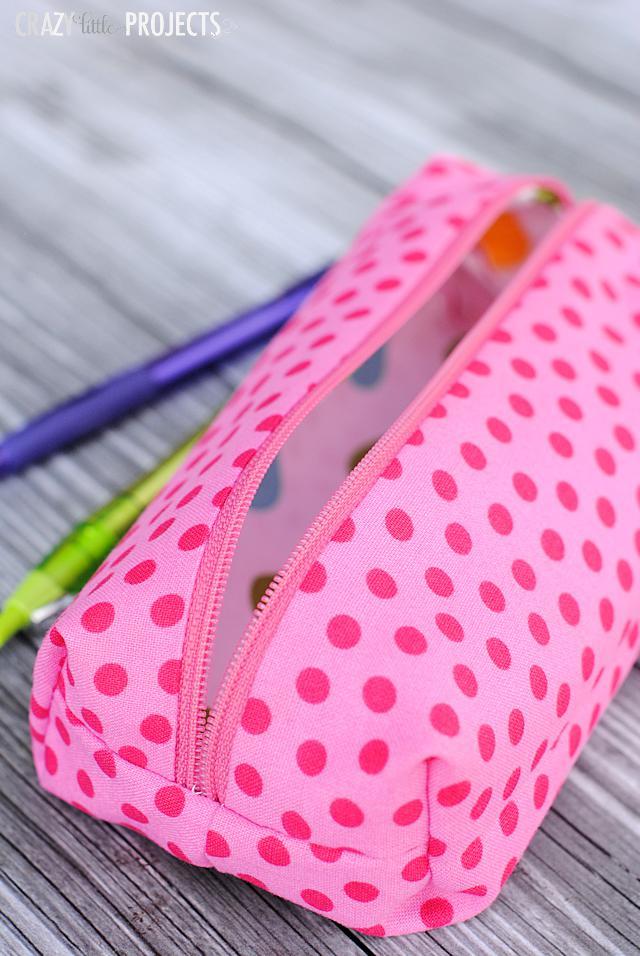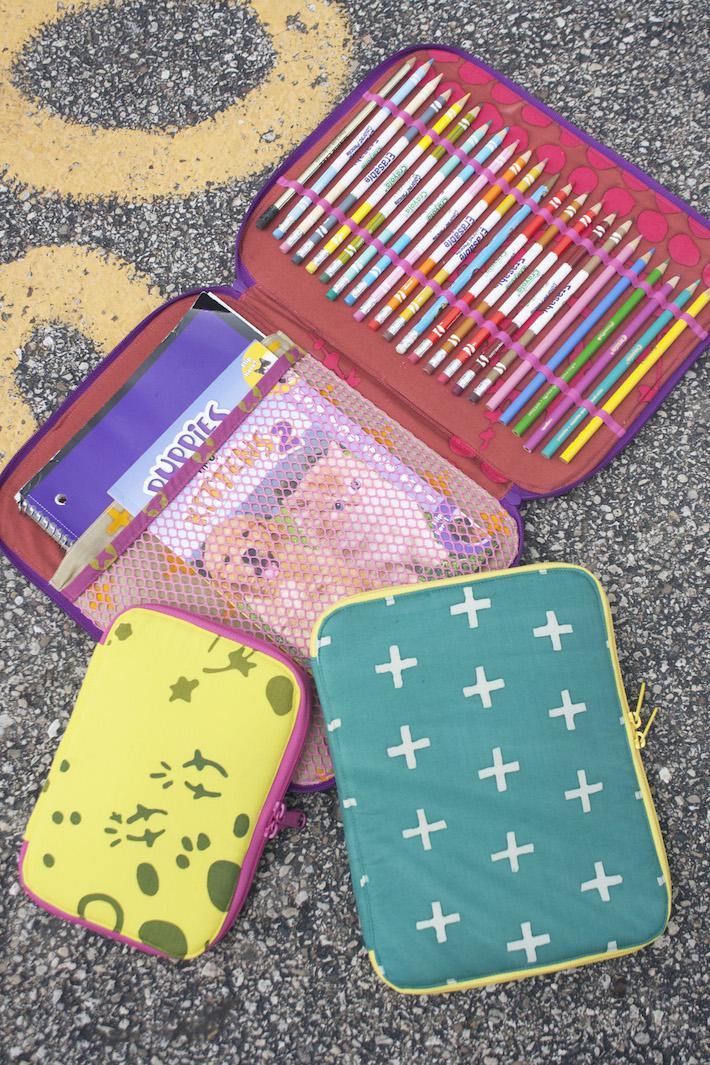The first image is the image on the left, the second image is the image on the right. Assess this claim about the two images: "There are at least 3 zipper pouches in the right image.". Correct or not? Answer yes or no. Yes. 